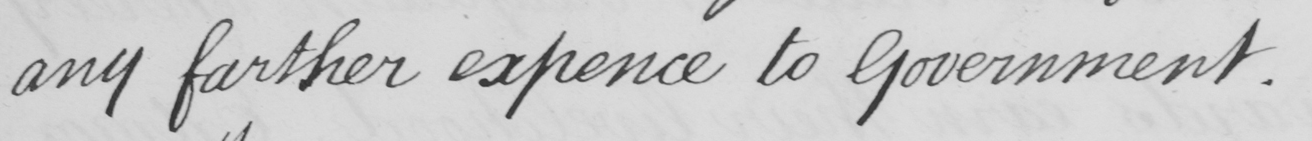Can you tell me what this handwritten text says? any further expence to Government . 